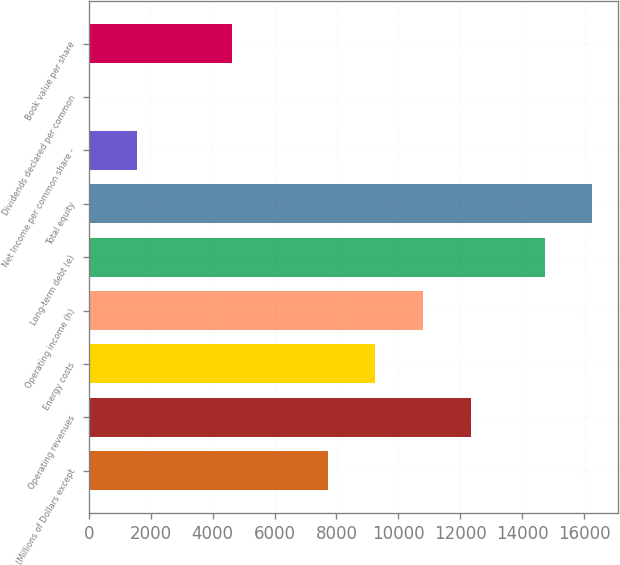<chart> <loc_0><loc_0><loc_500><loc_500><bar_chart><fcel>(Millions of Dollars except<fcel>Operating revenues<fcel>Energy costs<fcel>Operating income (h)<fcel>Long-term debt (e)<fcel>Total equity<fcel>Net Income per common share -<fcel>Dividends declared per common<fcel>Book value per share<nl><fcel>7713.86<fcel>12340.5<fcel>9256.08<fcel>10798.3<fcel>14731<fcel>16273.2<fcel>1544.98<fcel>2.76<fcel>4629.42<nl></chart> 